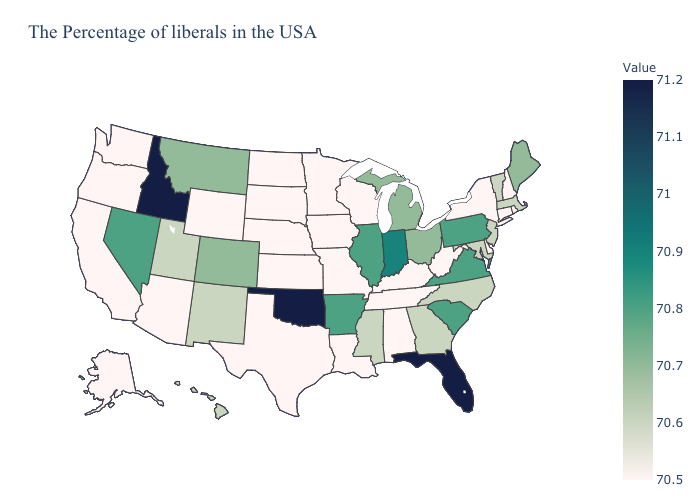Does Minnesota have the lowest value in the USA?
Short answer required. Yes. Does the map have missing data?
Give a very brief answer. No. Does the map have missing data?
Concise answer only. No. Which states hav the highest value in the MidWest?
Write a very short answer. Indiana. Does New Hampshire have the lowest value in the Northeast?
Concise answer only. Yes. Is the legend a continuous bar?
Answer briefly. Yes. Which states hav the highest value in the MidWest?
Keep it brief. Indiana. Does South Dakota have the lowest value in the USA?
Answer briefly. Yes. Which states hav the highest value in the West?
Quick response, please. Idaho. Does Minnesota have the lowest value in the MidWest?
Be succinct. Yes. Which states hav the highest value in the MidWest?
Keep it brief. Indiana. 